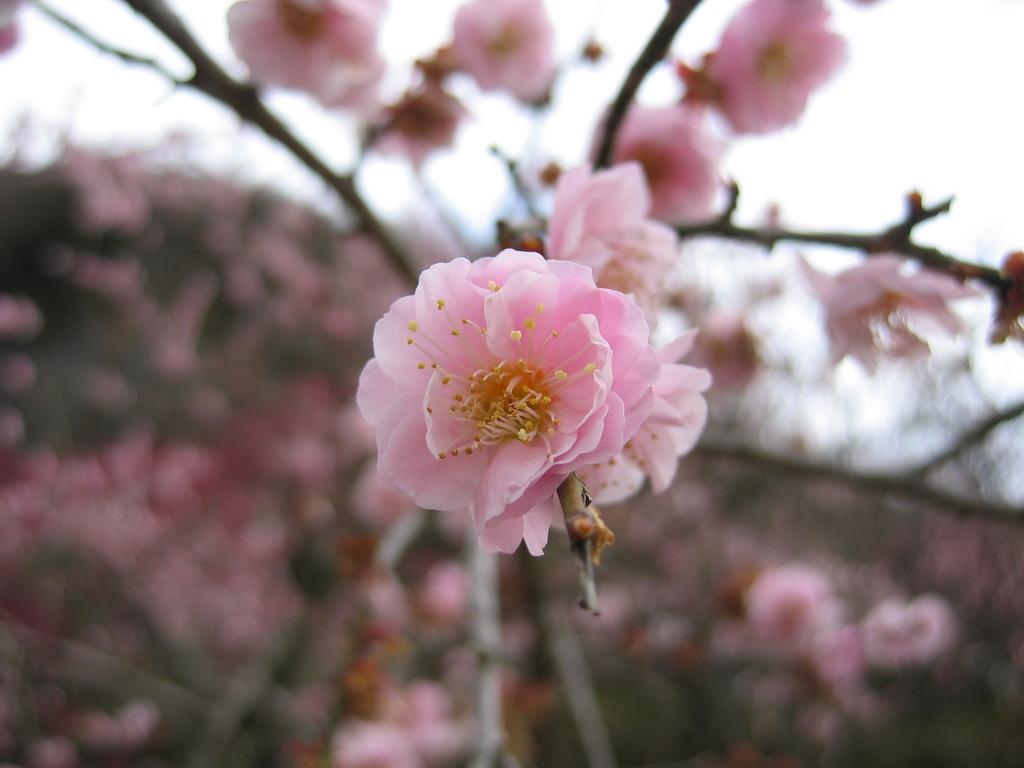Describe this image in one or two sentences. In this picture we can see few flowers and blurry background. 